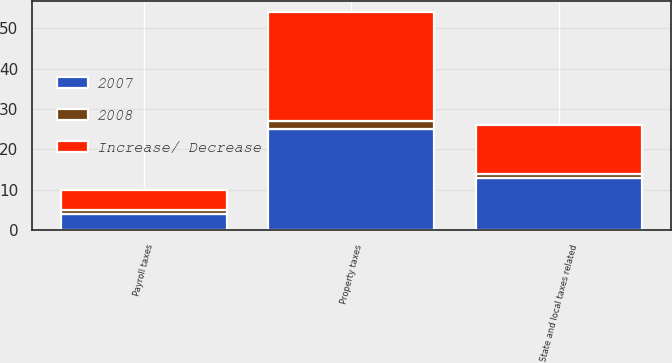<chart> <loc_0><loc_0><loc_500><loc_500><stacked_bar_chart><ecel><fcel>Property taxes<fcel>State and local taxes related<fcel>Payroll taxes<nl><fcel>Increase/ Decrease<fcel>27<fcel>12<fcel>5<nl><fcel>2007<fcel>25<fcel>13<fcel>4<nl><fcel>2008<fcel>2<fcel>1<fcel>1<nl></chart> 